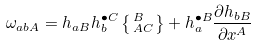<formula> <loc_0><loc_0><loc_500><loc_500>\omega _ { a b A } = h _ { a B } h _ { b } ^ { \bullet C } \left \{ \, ^ { B } _ { A C } \right \} + h _ { a } ^ { \bullet B } \frac { \partial h _ { b B } } { \partial x ^ { A } }</formula> 